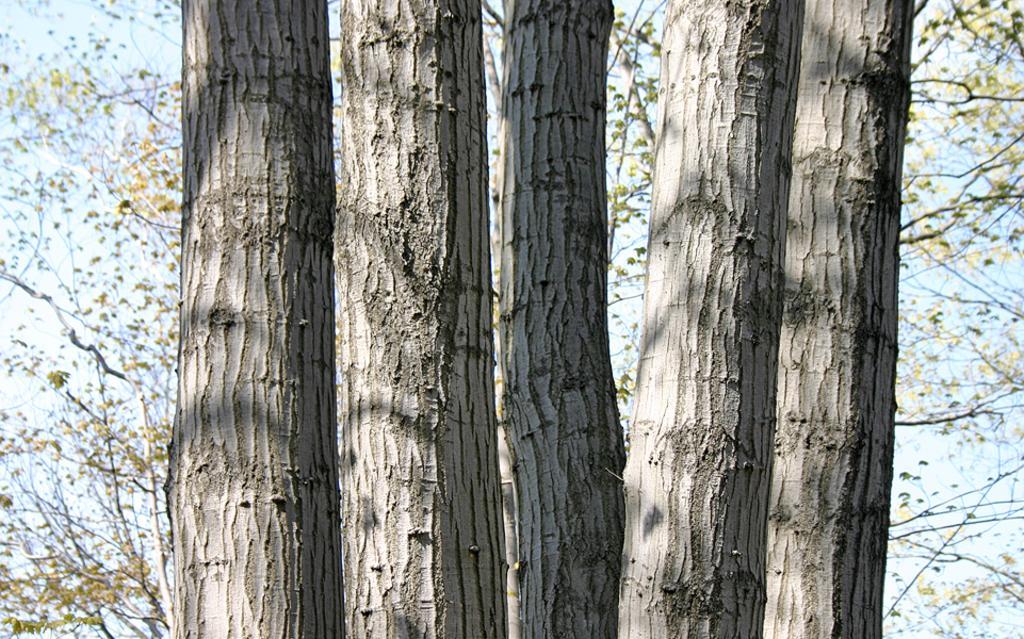Can you describe this image briefly? There are four tree trunks. In the background, I can see the branches with leaves. 